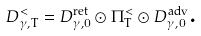<formula> <loc_0><loc_0><loc_500><loc_500>D _ { \gamma , \text {T} } ^ { < } = D _ { \gamma , 0 } ^ { \text {ret} } \odot \Pi _ { \text {T} } ^ { < } \odot D _ { \gamma , 0 } ^ { \text {adv} } \text {.}</formula> 